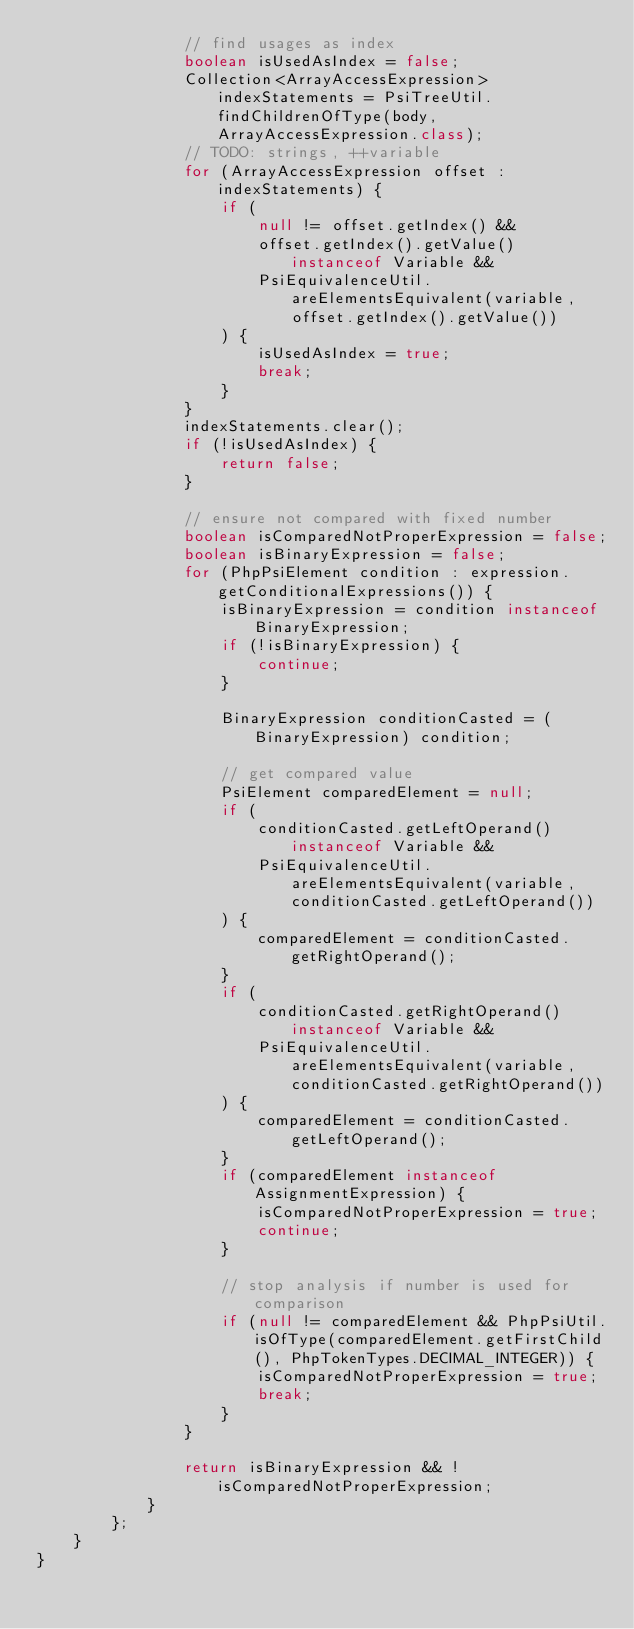Convert code to text. <code><loc_0><loc_0><loc_500><loc_500><_Java_>                // find usages as index
                boolean isUsedAsIndex = false;
                Collection<ArrayAccessExpression> indexStatements = PsiTreeUtil.findChildrenOfType(body, ArrayAccessExpression.class);
                // TODO: strings, ++variable
                for (ArrayAccessExpression offset : indexStatements) {
                    if (
                        null != offset.getIndex() &&
                        offset.getIndex().getValue() instanceof Variable &&
                        PsiEquivalenceUtil.areElementsEquivalent(variable, offset.getIndex().getValue())
                    ) {
                        isUsedAsIndex = true;
                        break;
                    }
                }
                indexStatements.clear();
                if (!isUsedAsIndex) {
                    return false;
                }

                // ensure not compared with fixed number
                boolean isComparedNotProperExpression = false;
                boolean isBinaryExpression = false;
                for (PhpPsiElement condition : expression.getConditionalExpressions()) {
                    isBinaryExpression = condition instanceof BinaryExpression;
                    if (!isBinaryExpression) {
                        continue;
                    }

                    BinaryExpression conditionCasted = (BinaryExpression) condition;

                    // get compared value
                    PsiElement comparedElement = null;
                    if (
                        conditionCasted.getLeftOperand() instanceof Variable &&
                        PsiEquivalenceUtil.areElementsEquivalent(variable, conditionCasted.getLeftOperand())
                    ) {
                        comparedElement = conditionCasted.getRightOperand();
                    }
                    if (
                        conditionCasted.getRightOperand() instanceof Variable &&
                        PsiEquivalenceUtil.areElementsEquivalent(variable, conditionCasted.getRightOperand())
                    ) {
                        comparedElement = conditionCasted.getLeftOperand();
                    }
                    if (comparedElement instanceof AssignmentExpression) {
                        isComparedNotProperExpression = true;
                        continue;
                    }

                    // stop analysis if number is used for comparison
                    if (null != comparedElement && PhpPsiUtil.isOfType(comparedElement.getFirstChild(), PhpTokenTypes.DECIMAL_INTEGER)) {
                        isComparedNotProperExpression = true;
                        break;
                    }
                }

                return isBinaryExpression && !isComparedNotProperExpression;
            }
        };
    }
}</code> 